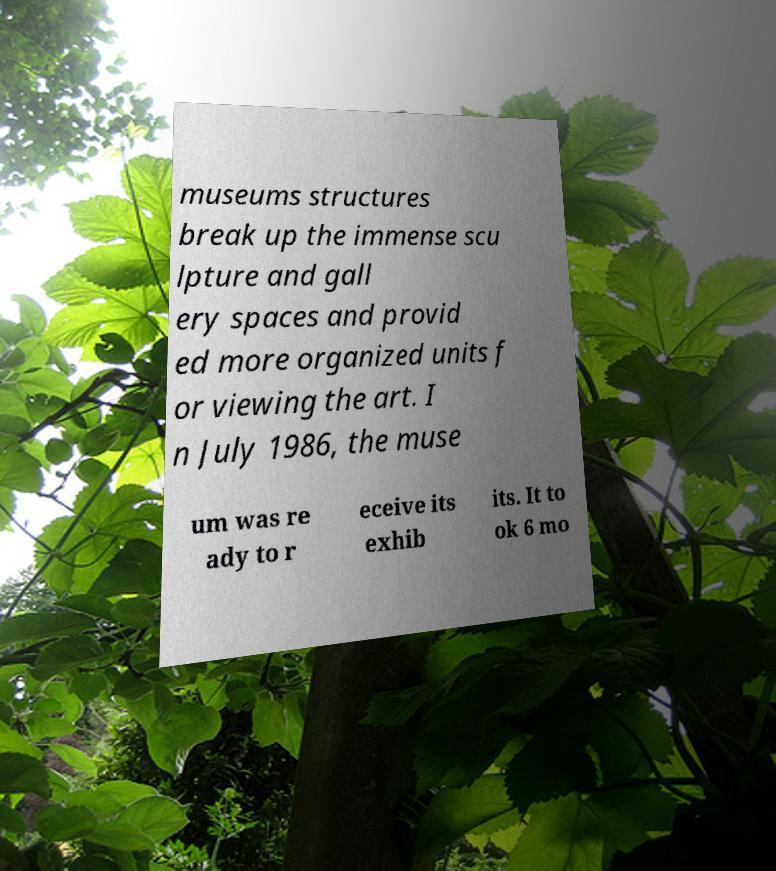For documentation purposes, I need the text within this image transcribed. Could you provide that? museums structures break up the immense scu lpture and gall ery spaces and provid ed more organized units f or viewing the art. I n July 1986, the muse um was re ady to r eceive its exhib its. It to ok 6 mo 